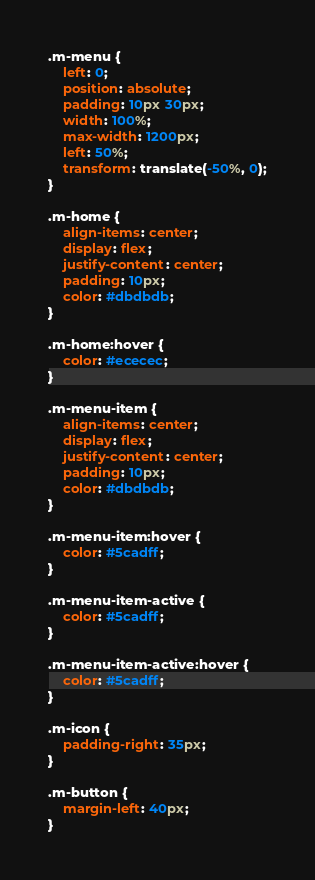Convert code to text. <code><loc_0><loc_0><loc_500><loc_500><_CSS_>.m-menu {
    left: 0;
    position: absolute;
    padding: 10px 30px;
    width: 100%;
    max-width: 1200px;
    left: 50%;
    transform: translate(-50%, 0);
}

.m-home {
    align-items: center;
    display: flex;
    justify-content: center;
    padding: 10px;
    color: #dbdbdb;
}

.m-home:hover {
    color: #ececec;
}

.m-menu-item {
    align-items: center;
    display: flex;
    justify-content: center;
    padding: 10px;
    color: #dbdbdb;
}

.m-menu-item:hover {
    color: #5cadff;
}

.m-menu-item-active {
    color: #5cadff;
}

.m-menu-item-active:hover {
    color: #5cadff;
}

.m-icon {
    padding-right: 35px;
}

.m-button {
    margin-left: 40px;
}
</code> 